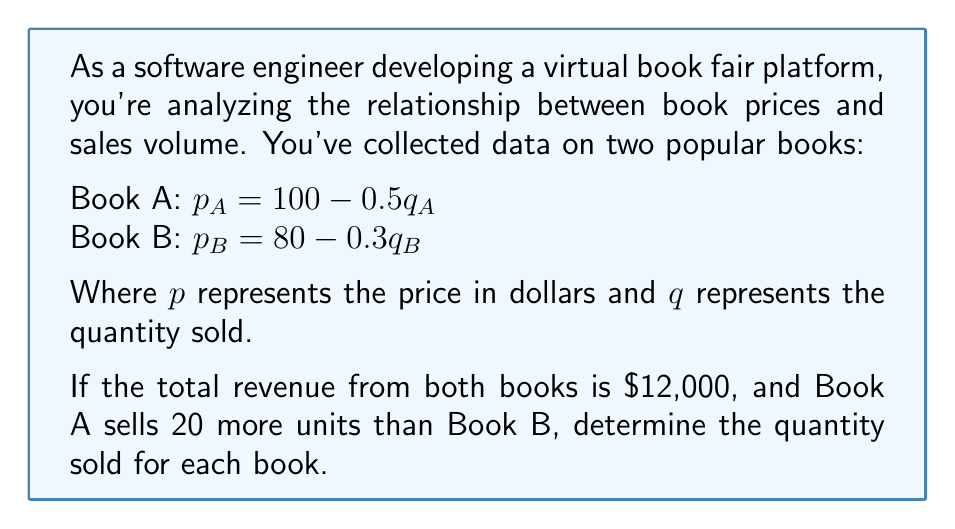What is the answer to this math problem? Let's approach this step-by-step:

1) Let $q_A$ be the quantity of Book A sold, and $q_B$ be the quantity of Book B sold.

2) We're given that $q_A = q_B + 20$

3) The revenue for each book is price times quantity. Total revenue is $12,000. So we can write:

   $p_A q_A + p_B q_B = 12000$

4) Substituting the price equations:

   $(100 - 0.5q_A)q_A + (80 - 0.3q_B)q_B = 12000$

5) Expand this equation:

   $100q_A - 0.5q_A^2 + 80q_B - 0.3q_B^2 = 12000$

6) Now, substitute $q_A = q_B + 20$ into this equation:

   $100(q_B + 20) - 0.5(q_B + 20)^2 + 80q_B - 0.3q_B^2 = 12000$

7) Expand further:

   $100q_B + 2000 - 0.5(q_B^2 + 40q_B + 400) + 80q_B - 0.3q_B^2 = 12000$
   
   $100q_B + 2000 - 0.5q_B^2 - 20q_B - 200 + 80q_B - 0.3q_B^2 = 12000$

8) Simplify:

   $-0.8q_B^2 + 160q_B + 1800 = 12000$
   
   $-0.8q_B^2 + 160q_B - 10200 = 0$

9) Multiply everything by -1.25 to simplify the coefficients:

   $q_B^2 - 200q_B + 12750 = 0$

10) This is a quadratic equation. We can solve it using the quadratic formula:

    $q_B = \frac{-b \pm \sqrt{b^2 - 4ac}}{2a}$

    Where $a=1$, $b=-200$, and $c=12750$

11) Solving:

    $q_B = \frac{200 \pm \sqrt{40000 - 51000}}{2} = \frac{200 \pm \sqrt{-11000}}{2}$

12) Since we can't have a negative under the square root for a real solution, and we can't have negative quantities sold, the only valid solution is:

    $q_B = 100$

13) Therefore, $q_A = q_B + 20 = 120$
Answer: Book A: 120 units
Book B: 100 units 